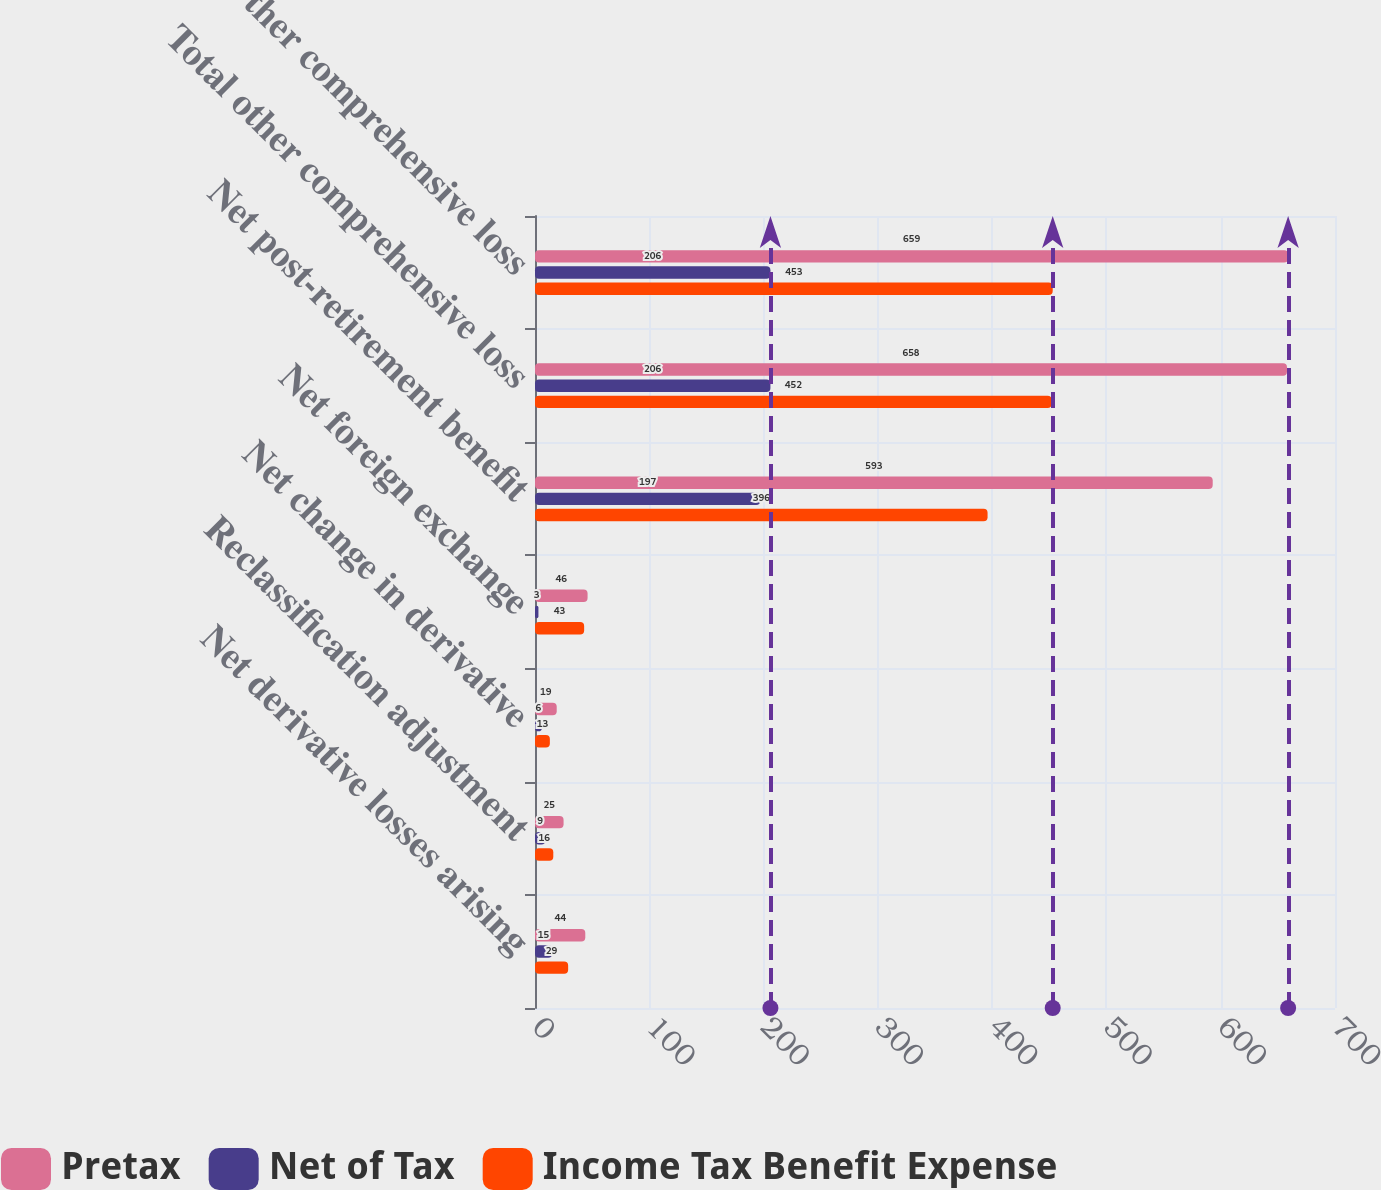Convert chart to OTSL. <chart><loc_0><loc_0><loc_500><loc_500><stacked_bar_chart><ecel><fcel>Net derivative losses arising<fcel>Reclassification adjustment<fcel>Net change in derivative<fcel>Net foreign exchange<fcel>Net post-retirement benefit<fcel>Total other comprehensive loss<fcel>Other comprehensive loss<nl><fcel>Pretax<fcel>44<fcel>25<fcel>19<fcel>46<fcel>593<fcel>658<fcel>659<nl><fcel>Net of Tax<fcel>15<fcel>9<fcel>6<fcel>3<fcel>197<fcel>206<fcel>206<nl><fcel>Income Tax Benefit Expense<fcel>29<fcel>16<fcel>13<fcel>43<fcel>396<fcel>452<fcel>453<nl></chart> 